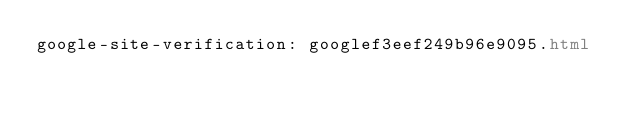Convert code to text. <code><loc_0><loc_0><loc_500><loc_500><_HTML_>google-site-verification: googlef3eef249b96e9095.html</code> 